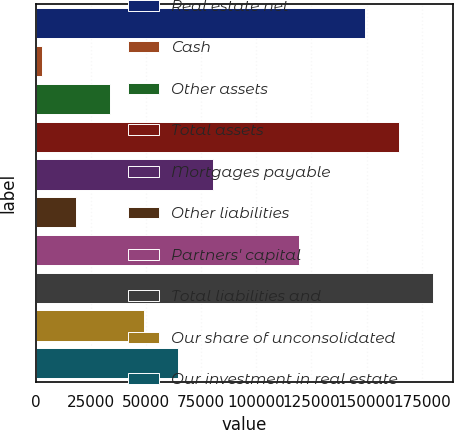<chart> <loc_0><loc_0><loc_500><loc_500><bar_chart><fcel>Real estate net<fcel>Cash<fcel>Other assets<fcel>Total assets<fcel>Mortgages payable<fcel>Other liabilities<fcel>Partners' capital<fcel>Total liabilities and<fcel>Our share of unconsolidated<fcel>Our investment in real estate<nl><fcel>149203<fcel>2864<fcel>33773.8<fcel>164658<fcel>80138.5<fcel>18318.9<fcel>119355<fcel>180113<fcel>49228.7<fcel>64683.6<nl></chart> 